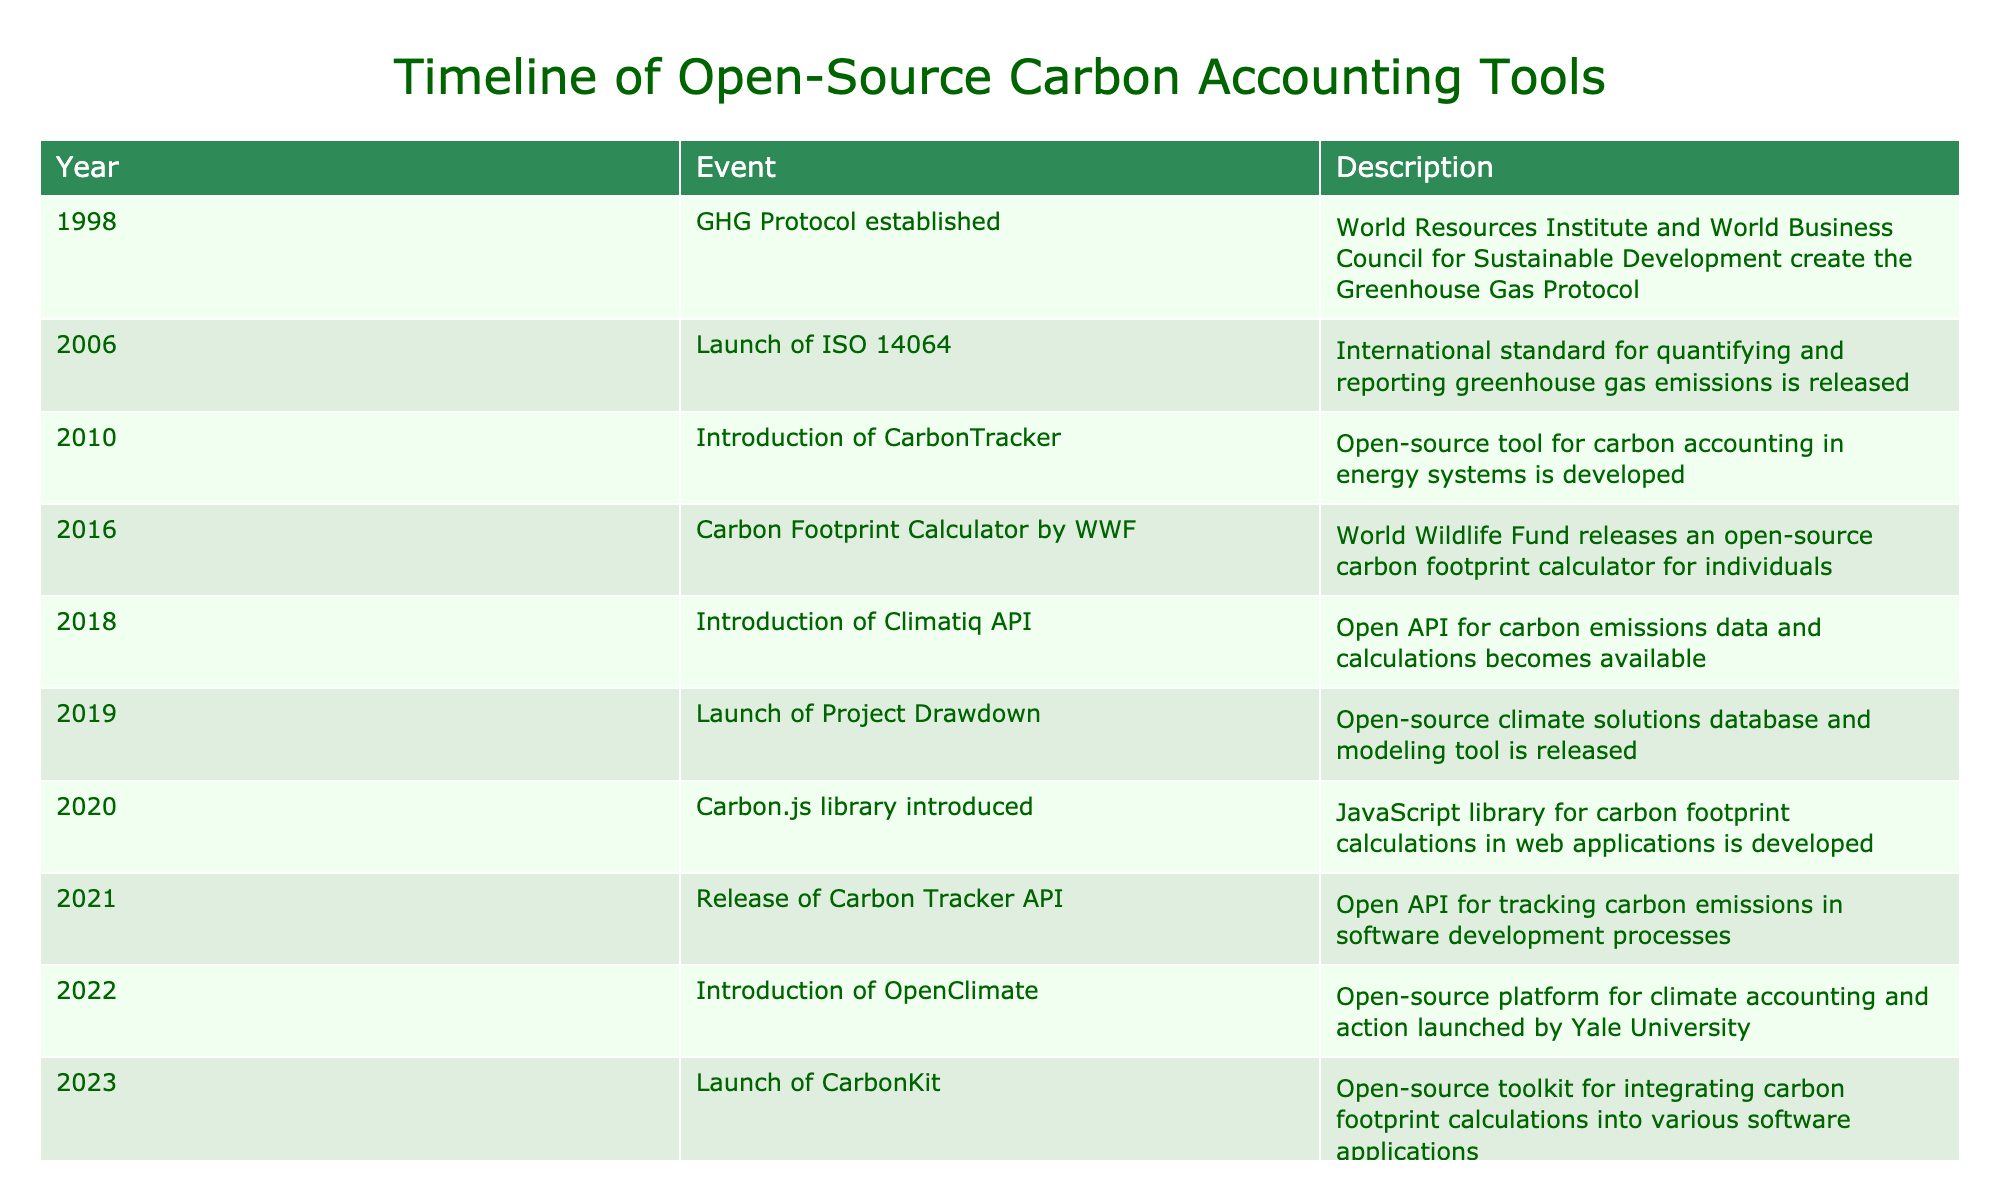What year was the GHG Protocol established? The table indicates that the GHG Protocol was established in 1998 under the event listed in the first row.
Answer: 1998 How many tools were launched between 2010 and 2020? From the table, the relevant years are: 2010 (CarbonTracker), 2016 (WWF Carbon Footprint Calculator), 2019 (Project Drawdown), and 2020 (Carbon.js library).  Counting these events gives us a total of 4 tools.
Answer: 4 Did the introduction of the Climatiq API occur before or after the release of the Carbon.js library? The table shows that the Climatiq API was introduced in 2018 and the Carbon.js library in 2020. Since 2018 comes before 2020, the Climatiq API was introduced first.
Answer: Before What is the difference in years between the launch of OpenClimate and the establishment of the GHG Protocol? The launch of OpenClimate occurred in 2022 and the GHG Protocol was established in 1998. Calculating the difference gives us 2022 - 1998 = 24 years.
Answer: 24 years How many milestones were established in the 2010s? Reviewing the table, the milestones in the 2010s are from 2010 (CarbonTracker), 2016 (WWF Carbon Footprint Calculator), 2018 (Climatiq API), and 2019 (Project Drawdown). This results in a total of 4 milestones in that decade.
Answer: 4 Is there an open-source tool related to carbon accounting that was released in 2021? From the table, it states that the Carbon Tracker API was released in 2021. Therefore, the answer is yes, there is an open-source tool released that year.
Answer: Yes What is the chronological order of the events listed from 2010 to 2020? The events listed in order are: 2010 (CarbonTracker), 2016 (WWF Carbon Footprint Calculator), 2018 (Climatiq API), 2019 (Project Drawdown), and 2020 (Carbon.js library). This sequence shows the development timeline from the earliest to the latest event within those years.
Answer: CarbonTracker, WWF Carbon Footprint Calculator, Climatiq API, Project Drawdown, Carbon.js library Which event marks the introduction of an open-source API for tracking carbon emissions in software development? The table indicates that the event for this was the release of the Carbon Tracker API in 2021, marking it as the introduction of an open-source API for that purpose.
Answer: Release of Carbon Tracker API in 2021 